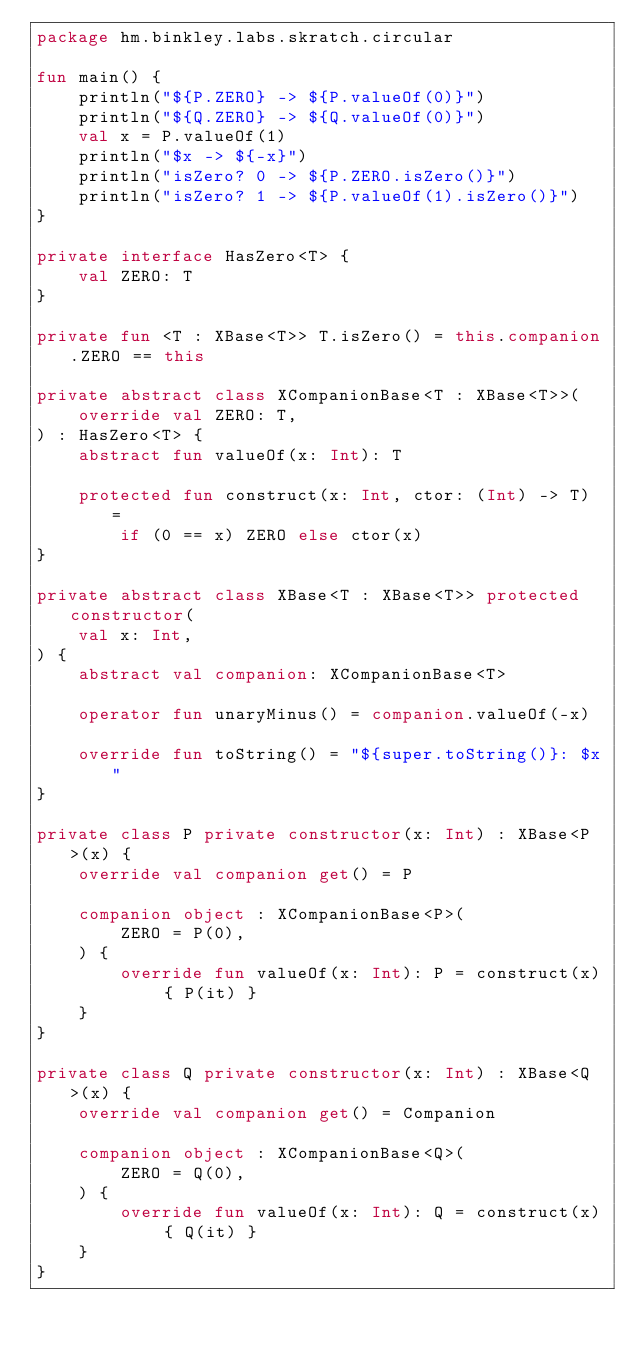<code> <loc_0><loc_0><loc_500><loc_500><_Kotlin_>package hm.binkley.labs.skratch.circular

fun main() {
    println("${P.ZERO} -> ${P.valueOf(0)}")
    println("${Q.ZERO} -> ${Q.valueOf(0)}")
    val x = P.valueOf(1)
    println("$x -> ${-x}")
    println("isZero? 0 -> ${P.ZERO.isZero()}")
    println("isZero? 1 -> ${P.valueOf(1).isZero()}")
}

private interface HasZero<T> {
    val ZERO: T
}

private fun <T : XBase<T>> T.isZero() = this.companion.ZERO == this

private abstract class XCompanionBase<T : XBase<T>>(
    override val ZERO: T,
) : HasZero<T> {
    abstract fun valueOf(x: Int): T

    protected fun construct(x: Int, ctor: (Int) -> T) =
        if (0 == x) ZERO else ctor(x)
}

private abstract class XBase<T : XBase<T>> protected constructor(
    val x: Int,
) {
    abstract val companion: XCompanionBase<T>

    operator fun unaryMinus() = companion.valueOf(-x)

    override fun toString() = "${super.toString()}: $x"
}

private class P private constructor(x: Int) : XBase<P>(x) {
    override val companion get() = P

    companion object : XCompanionBase<P>(
        ZERO = P(0),
    ) {
        override fun valueOf(x: Int): P = construct(x) { P(it) }
    }
}

private class Q private constructor(x: Int) : XBase<Q>(x) {
    override val companion get() = Companion

    companion object : XCompanionBase<Q>(
        ZERO = Q(0),
    ) {
        override fun valueOf(x: Int): Q = construct(x) { Q(it) }
    }
}
</code> 